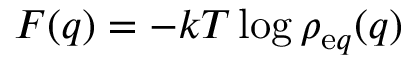Convert formula to latex. <formula><loc_0><loc_0><loc_500><loc_500>F ( q ) = - k T \log \rho _ { \mathrm e q } ( q )</formula> 